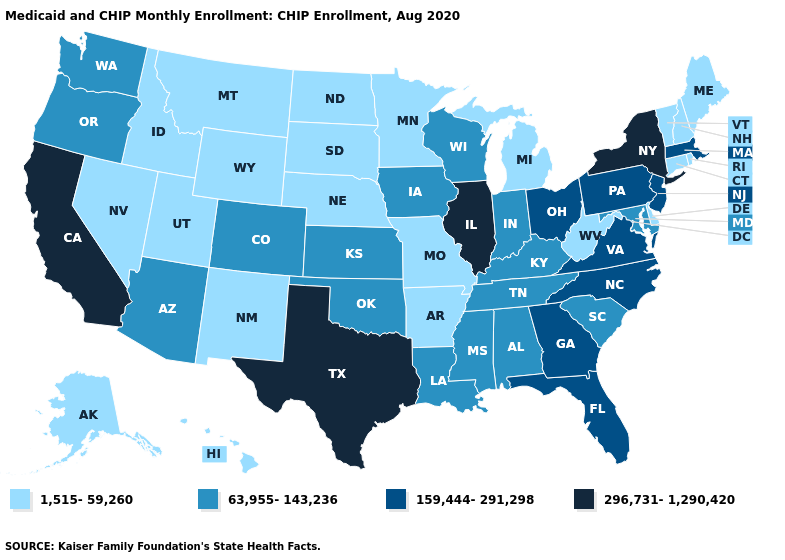Does Wisconsin have the same value as Texas?
Write a very short answer. No. Does the map have missing data?
Short answer required. No. Among the states that border Idaho , does Wyoming have the highest value?
Short answer required. No. Does Washington have a higher value than Montana?
Short answer required. Yes. Name the states that have a value in the range 296,731-1,290,420?
Answer briefly. California, Illinois, New York, Texas. What is the lowest value in the West?
Write a very short answer. 1,515-59,260. Which states hav the highest value in the South?
Short answer required. Texas. What is the value of Kansas?
Quick response, please. 63,955-143,236. Name the states that have a value in the range 1,515-59,260?
Short answer required. Alaska, Arkansas, Connecticut, Delaware, Hawaii, Idaho, Maine, Michigan, Minnesota, Missouri, Montana, Nebraska, Nevada, New Hampshire, New Mexico, North Dakota, Rhode Island, South Dakota, Utah, Vermont, West Virginia, Wyoming. Which states hav the highest value in the South?
Concise answer only. Texas. Does Delaware have the lowest value in the South?
Short answer required. Yes. Among the states that border Florida , does Alabama have the lowest value?
Quick response, please. Yes. Which states hav the highest value in the Northeast?
Keep it brief. New York. What is the value of Alabama?
Concise answer only. 63,955-143,236. Name the states that have a value in the range 1,515-59,260?
Short answer required. Alaska, Arkansas, Connecticut, Delaware, Hawaii, Idaho, Maine, Michigan, Minnesota, Missouri, Montana, Nebraska, Nevada, New Hampshire, New Mexico, North Dakota, Rhode Island, South Dakota, Utah, Vermont, West Virginia, Wyoming. 